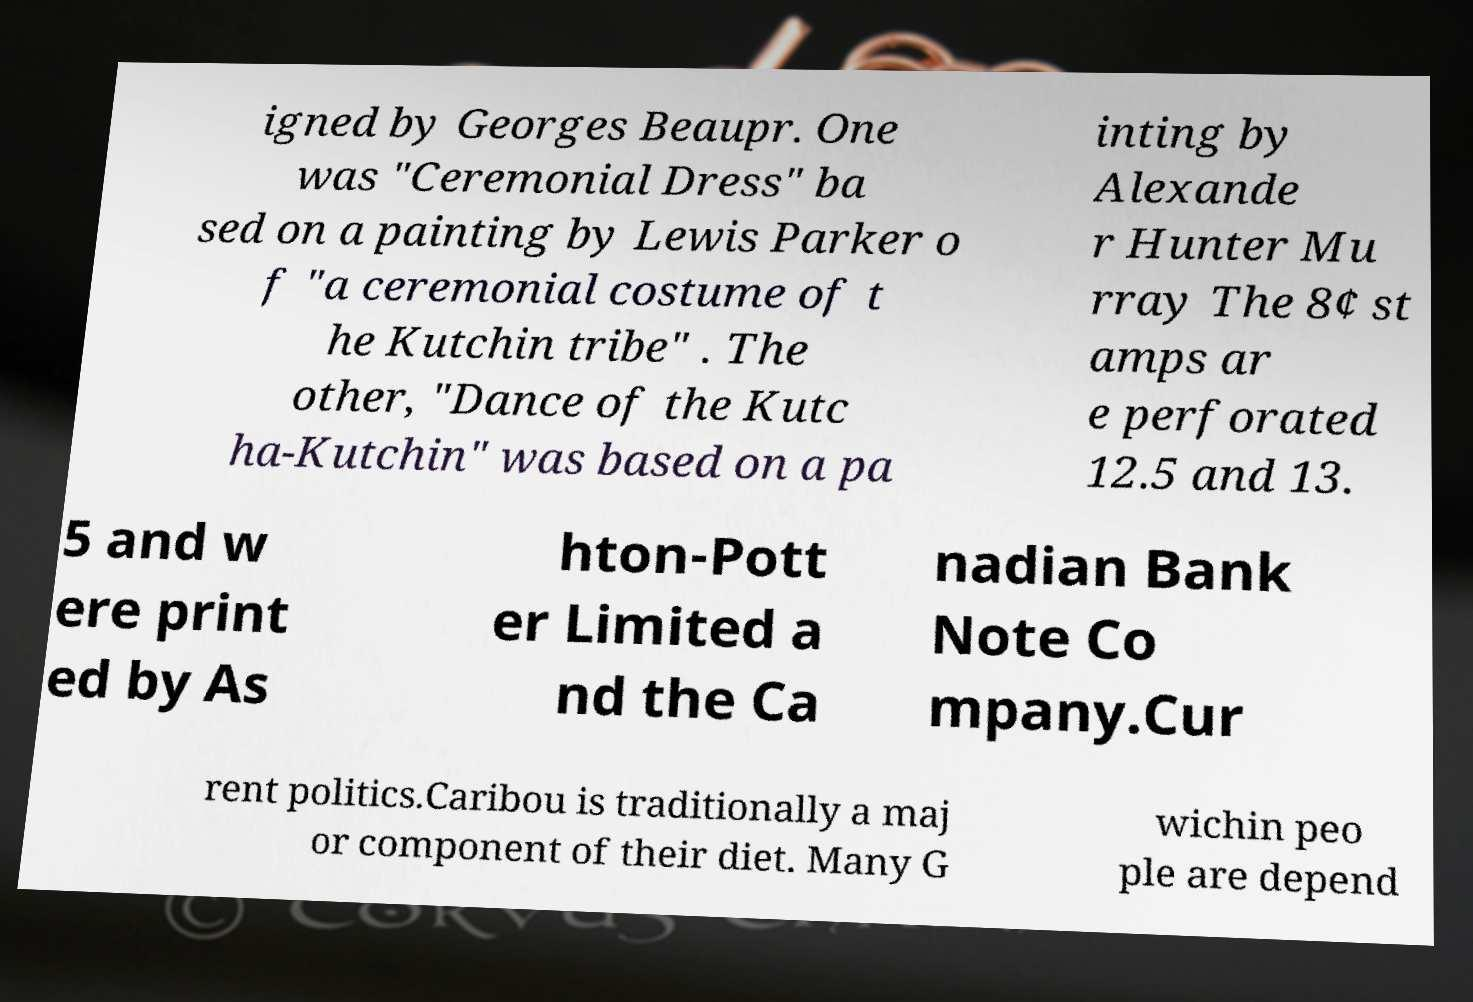What messages or text are displayed in this image? I need them in a readable, typed format. igned by Georges Beaupr. One was "Ceremonial Dress" ba sed on a painting by Lewis Parker o f "a ceremonial costume of t he Kutchin tribe" . The other, "Dance of the Kutc ha-Kutchin" was based on a pa inting by Alexande r Hunter Mu rray The 8¢ st amps ar e perforated 12.5 and 13. 5 and w ere print ed by As hton-Pott er Limited a nd the Ca nadian Bank Note Co mpany.Cur rent politics.Caribou is traditionally a maj or component of their diet. Many G wichin peo ple are depend 